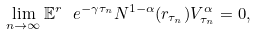Convert formula to latex. <formula><loc_0><loc_0><loc_500><loc_500>\lim _ { n \to \infty } \mathbb { E } ^ { r } \ e ^ { - \gamma \tau _ { n } } N ^ { 1 - \alpha } ( r _ { \tau _ { n } } ) V _ { \tau _ { n } } ^ { \alpha } = 0 ,</formula> 